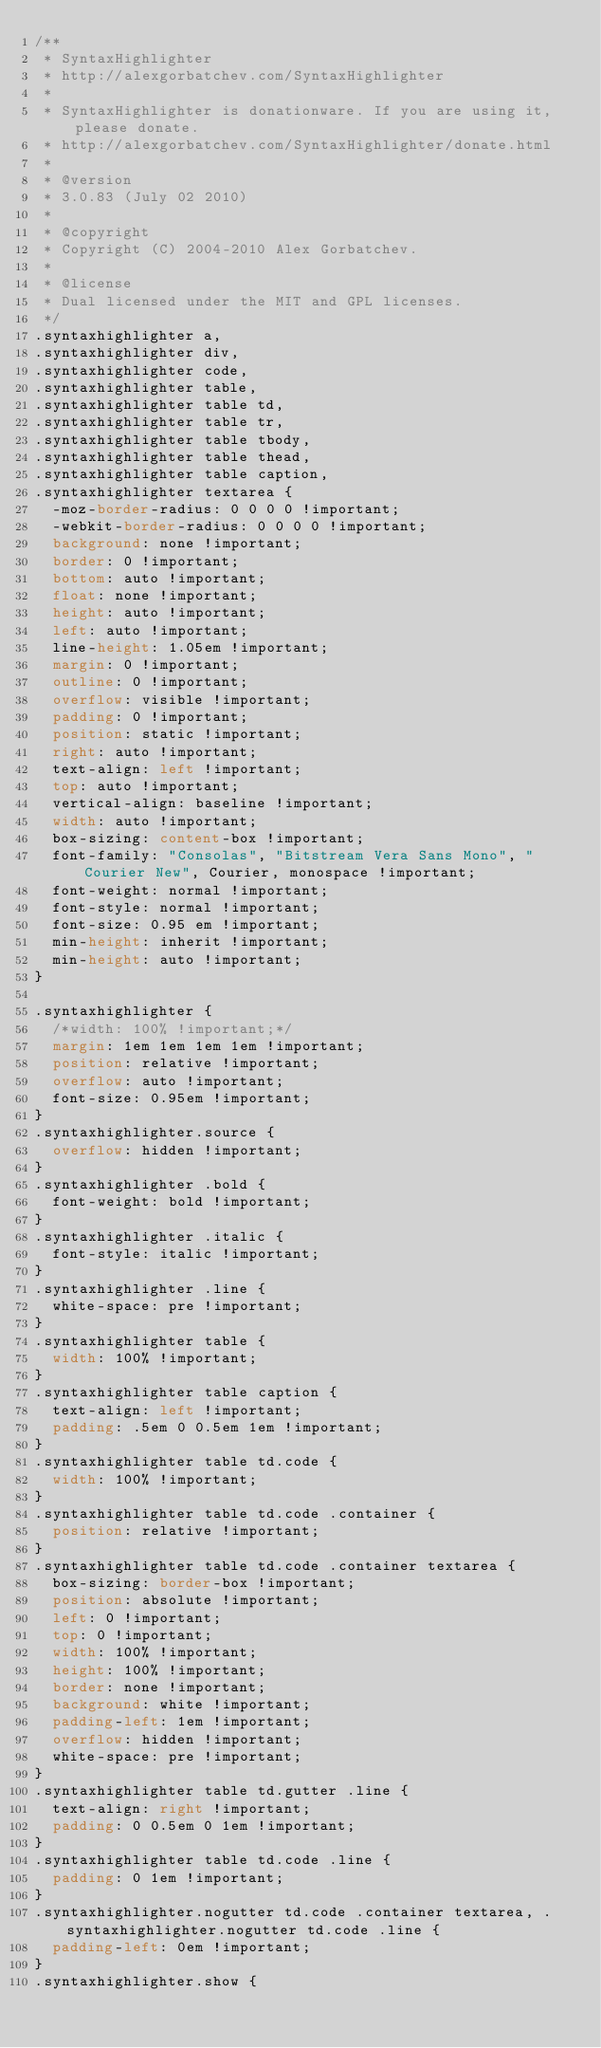<code> <loc_0><loc_0><loc_500><loc_500><_CSS_>/**
 * SyntaxHighlighter
 * http://alexgorbatchev.com/SyntaxHighlighter
 *
 * SyntaxHighlighter is donationware. If you are using it, please donate.
 * http://alexgorbatchev.com/SyntaxHighlighter/donate.html
 *
 * @version
 * 3.0.83 (July 02 2010)
 * 
 * @copyright
 * Copyright (C) 2004-2010 Alex Gorbatchev.
 *
 * @license
 * Dual licensed under the MIT and GPL licenses.
 */
.syntaxhighlighter a,
.syntaxhighlighter div,
.syntaxhighlighter code,
.syntaxhighlighter table,
.syntaxhighlighter table td,
.syntaxhighlighter table tr,
.syntaxhighlighter table tbody,
.syntaxhighlighter table thead,
.syntaxhighlighter table caption,
.syntaxhighlighter textarea {
  -moz-border-radius: 0 0 0 0 !important;
  -webkit-border-radius: 0 0 0 0 !important;
  background: none !important;
  border: 0 !important;
  bottom: auto !important;
  float: none !important;
  height: auto !important;
  left: auto !important;
  line-height: 1.05em !important;
  margin: 0 !important;
  outline: 0 !important;
  overflow: visible !important;
  padding: 0 !important;
  position: static !important;
  right: auto !important;
  text-align: left !important;
  top: auto !important;
  vertical-align: baseline !important;
  width: auto !important;
  box-sizing: content-box !important;
  font-family: "Consolas", "Bitstream Vera Sans Mono", "Courier New", Courier, monospace !important;
  font-weight: normal !important;
  font-style: normal !important;
  font-size: 0.95 em !important;
  min-height: inherit !important;
  min-height: auto !important;
}

.syntaxhighlighter {
  /*width: 100% !important;*/
  margin: 1em 1em 1em 1em !important;
  position: relative !important;
  overflow: auto !important;
  font-size: 0.95em !important;
}
.syntaxhighlighter.source {
  overflow: hidden !important;
}
.syntaxhighlighter .bold {
  font-weight: bold !important;
}
.syntaxhighlighter .italic {
  font-style: italic !important;
}
.syntaxhighlighter .line {
  white-space: pre !important;
}
.syntaxhighlighter table {
  width: 100% !important;
}
.syntaxhighlighter table caption {
  text-align: left !important;
  padding: .5em 0 0.5em 1em !important;
}
.syntaxhighlighter table td.code {
  width: 100% !important;
}
.syntaxhighlighter table td.code .container {
  position: relative !important;
}
.syntaxhighlighter table td.code .container textarea {
  box-sizing: border-box !important;
  position: absolute !important;
  left: 0 !important;
  top: 0 !important;
  width: 100% !important;
  height: 100% !important;
  border: none !important;
  background: white !important;
  padding-left: 1em !important;
  overflow: hidden !important;
  white-space: pre !important;
}
.syntaxhighlighter table td.gutter .line {
  text-align: right !important;
  padding: 0 0.5em 0 1em !important;
}
.syntaxhighlighter table td.code .line {
  padding: 0 1em !important;
}
.syntaxhighlighter.nogutter td.code .container textarea, .syntaxhighlighter.nogutter td.code .line {
  padding-left: 0em !important;
}
.syntaxhighlighter.show {</code> 